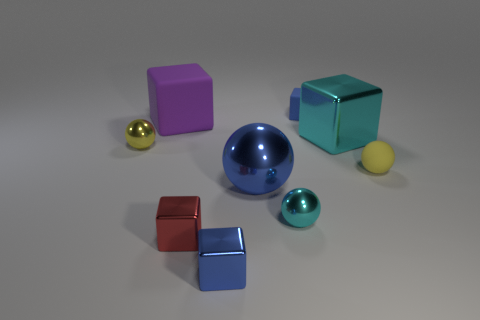Subtract 1 balls. How many balls are left? 3 Subtract all cyan blocks. How many blocks are left? 4 Subtract all tiny matte cubes. How many cubes are left? 4 Subtract all green cubes. Subtract all gray cylinders. How many cubes are left? 5 Add 1 small yellow metallic blocks. How many objects exist? 10 Subtract all spheres. How many objects are left? 5 Add 3 large green things. How many large green things exist? 3 Subtract 1 blue blocks. How many objects are left? 8 Subtract all cyan cubes. Subtract all tiny cyan balls. How many objects are left? 7 Add 5 tiny matte spheres. How many tiny matte spheres are left? 6 